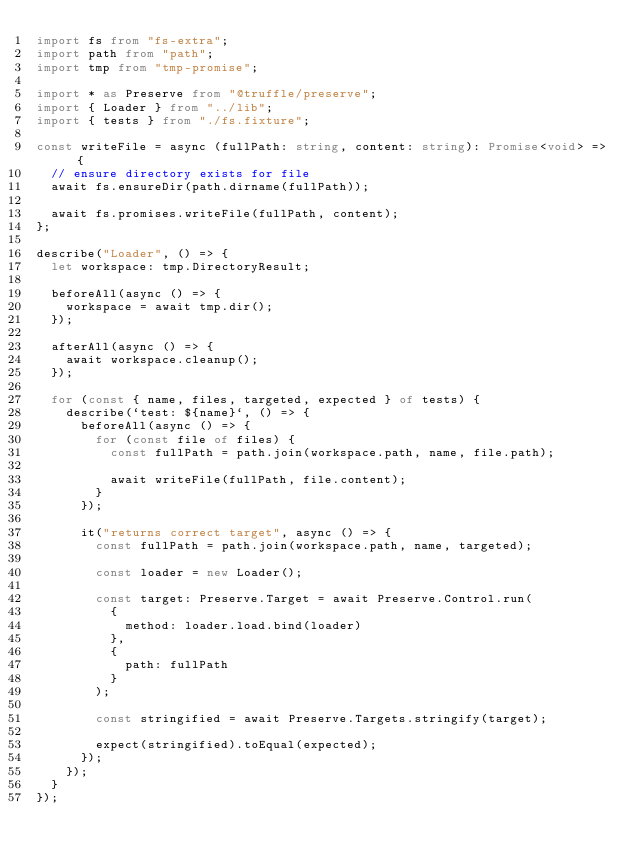<code> <loc_0><loc_0><loc_500><loc_500><_TypeScript_>import fs from "fs-extra";
import path from "path";
import tmp from "tmp-promise";

import * as Preserve from "@truffle/preserve";
import { Loader } from "../lib";
import { tests } from "./fs.fixture";

const writeFile = async (fullPath: string, content: string): Promise<void> => {
  // ensure directory exists for file
  await fs.ensureDir(path.dirname(fullPath));

  await fs.promises.writeFile(fullPath, content);
};

describe("Loader", () => {
  let workspace: tmp.DirectoryResult;

  beforeAll(async () => {
    workspace = await tmp.dir();
  });

  afterAll(async () => {
    await workspace.cleanup();
  });

  for (const { name, files, targeted, expected } of tests) {
    describe(`test: ${name}`, () => {
      beforeAll(async () => {
        for (const file of files) {
          const fullPath = path.join(workspace.path, name, file.path);

          await writeFile(fullPath, file.content);
        }
      });

      it("returns correct target", async () => {
        const fullPath = path.join(workspace.path, name, targeted);

        const loader = new Loader();

        const target: Preserve.Target = await Preserve.Control.run(
          {
            method: loader.load.bind(loader)
          },
          {
            path: fullPath
          }
        );

        const stringified = await Preserve.Targets.stringify(target);

        expect(stringified).toEqual(expected);
      });
    });
  }
});
</code> 